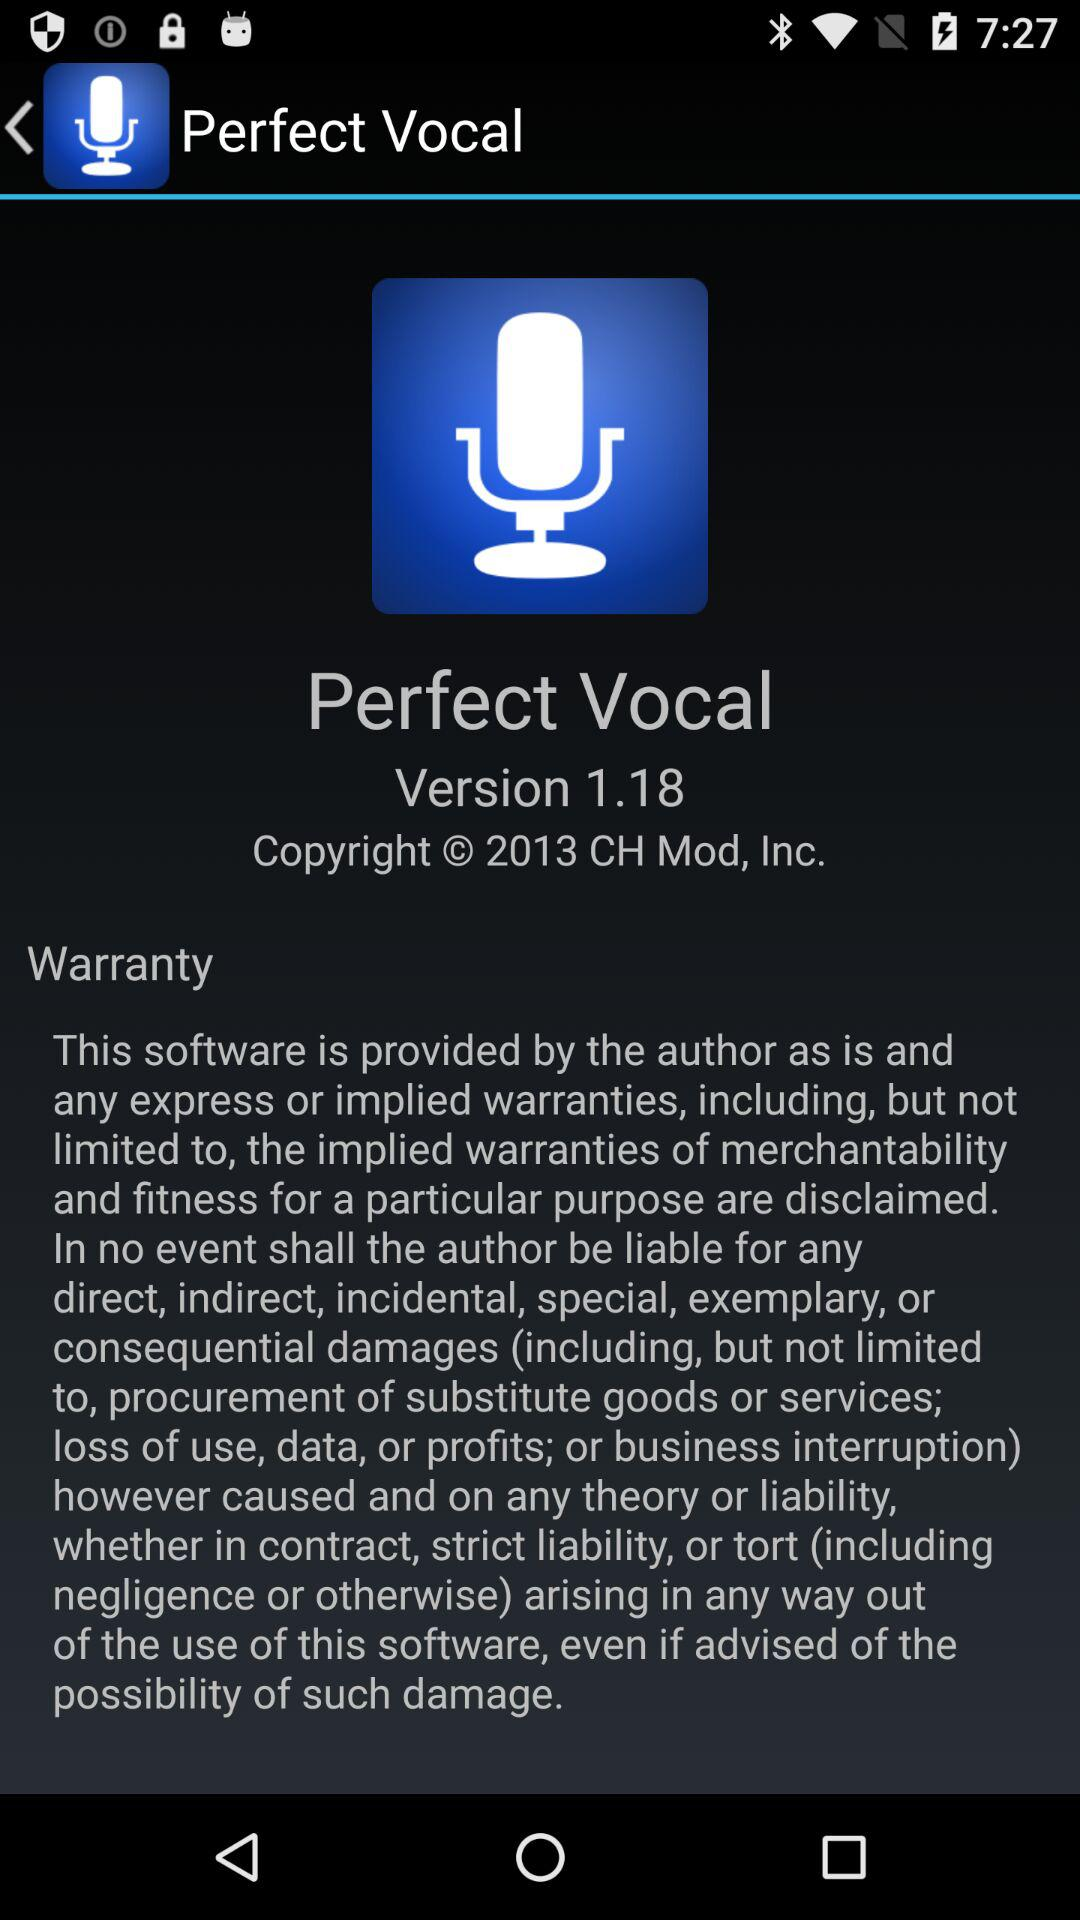How much does the application cost?
When the provided information is insufficient, respond with <no answer>. <no answer> 